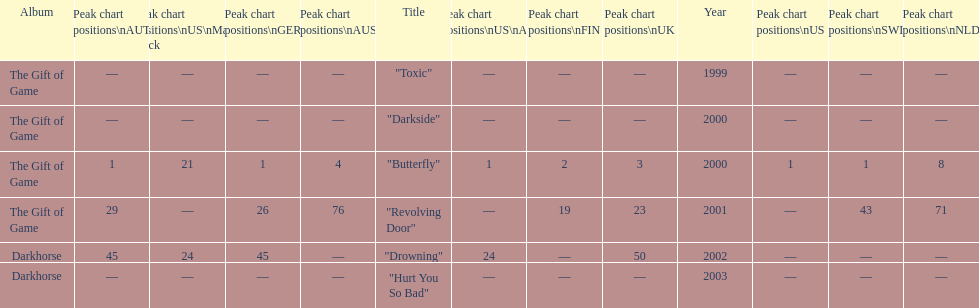How many singles have a ranking of 1 under ger? 1. 